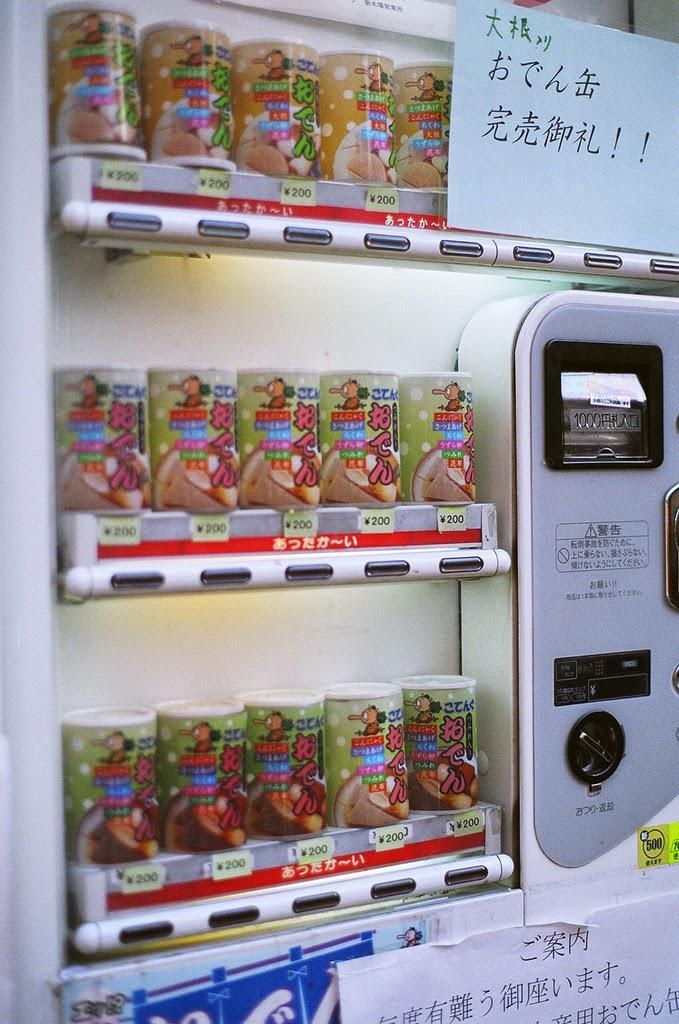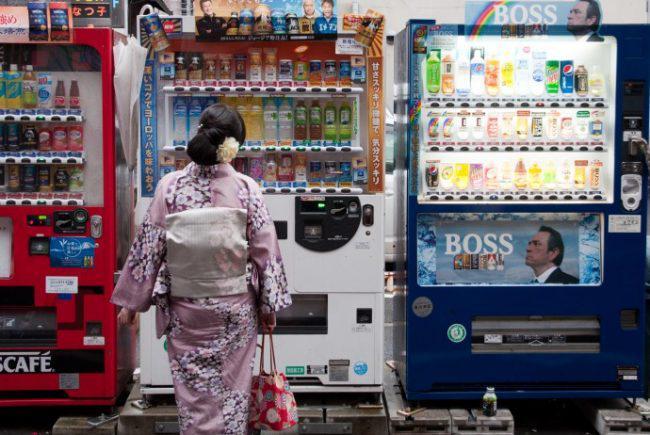The first image is the image on the left, the second image is the image on the right. For the images displayed, is the sentence "There is a red vending machine in one of the images" factually correct? Answer yes or no. Yes. The first image is the image on the left, the second image is the image on the right. Assess this claim about the two images: "One of the images contains more than one vending machine.". Correct or not? Answer yes or no. Yes. 